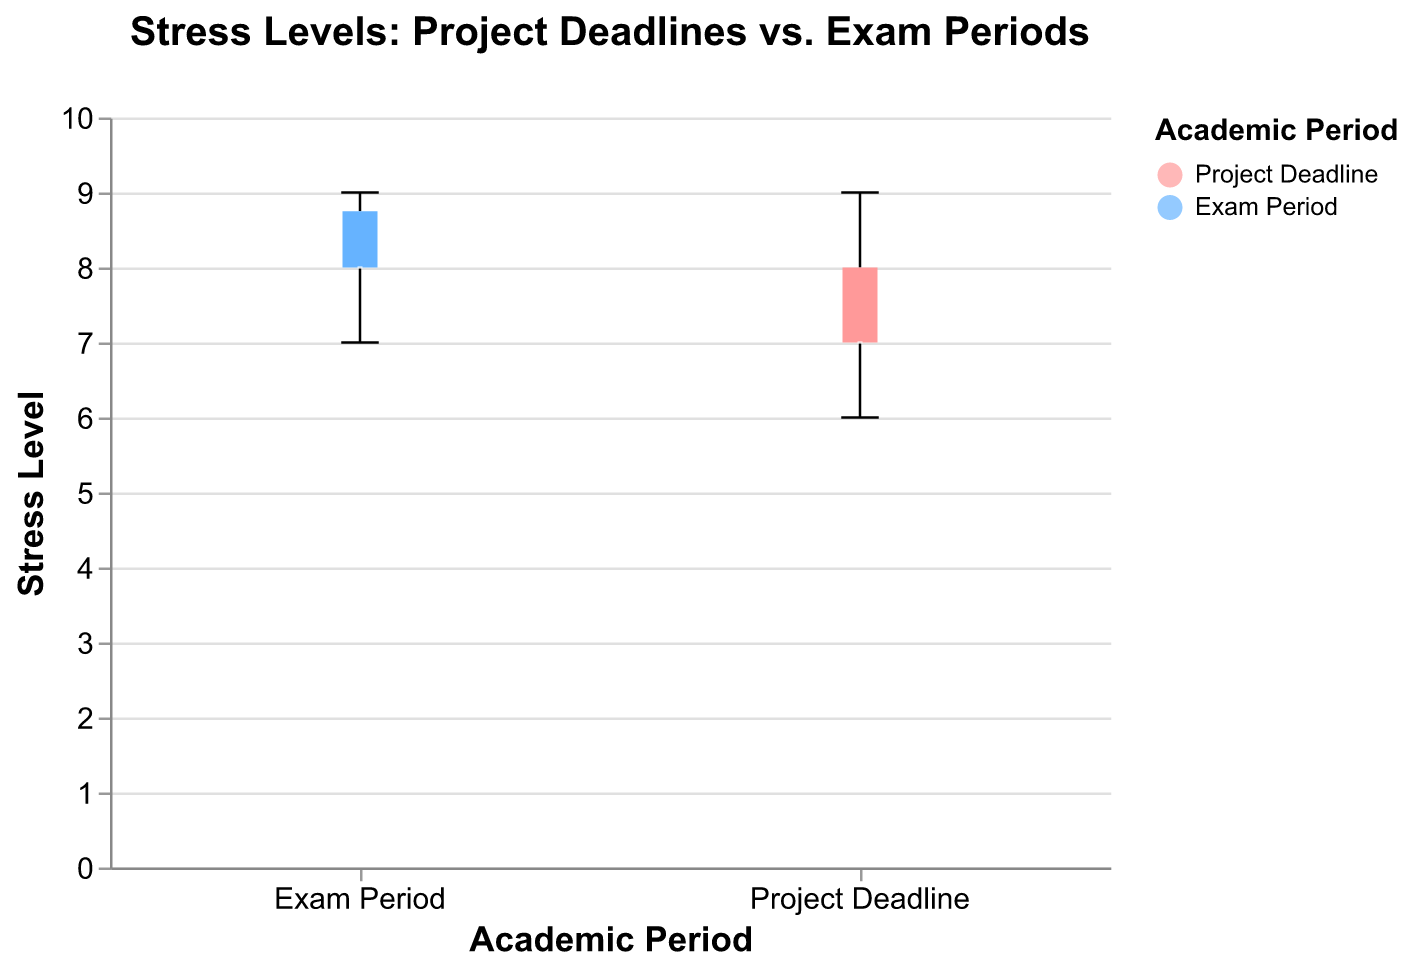What is the title of the figure? The title can be found at the top of the figure, which summarizes its content.
Answer: Stress Levels: Project Deadlines vs. Exam Periods What are the two periods compared in the figure? The periods compared on the x-axis of the grouped box plot are labeled, indicating two distinct time frames.
Answer: Project Deadline and Exam Period What is the range of stress levels during the Project Deadline period? The range can be seen by looking at the whiskers of the box plot for the Project Deadline group. The minimum and maximum values are the extremes of these whiskers.
Answer: 6 to 9 What is the median stress level during the Exam Period? The median is represented by the line inside the box for the Exam Period group.
Answer: 8 How do the stress levels compare between the Project Deadline and Exam Period? To compare these, observe the box plots for both periods. Notice the median lines and the spread of the boxes.
Answer: Stress levels are generally higher during Exam Period What is the interquartile range (IQR) of stress levels during the Project Deadline period? The IQR is the distance between the first quartile (Q1) and the third quartile (Q3). It is the length of the box in the box plot for the Project Deadline group.
Answer: 1 (from 7 to 8) Which period shows a higher maximum stress level? The maximum stress level is indicated by the top whisker of each box plot. Compare these whiskers for both periods.
Answer: Exam Period Is there any overlap in the range of stress levels between the two periods? Look at the whiskers of both box plots. If they overlap, there is an overlap in the range of stress levels.
Answer: Yes What is the minimum stress level observed during the Exam Period? The minimum stress level is indicated by the bottom whisker of the box plot for the Exam Period group.
Answer: 7 Which period shows less variability in stress levels? Variability can be assessed by the length of the box and whiskers in each box plot. The shorter lengths indicate less variability.
Answer: Exam Period Is the median stress level higher during the Project Deadline period or the Exam Period? Compare the median lines inside the boxes of both groups for a direct visual comparison.
Answer: Exam Period 